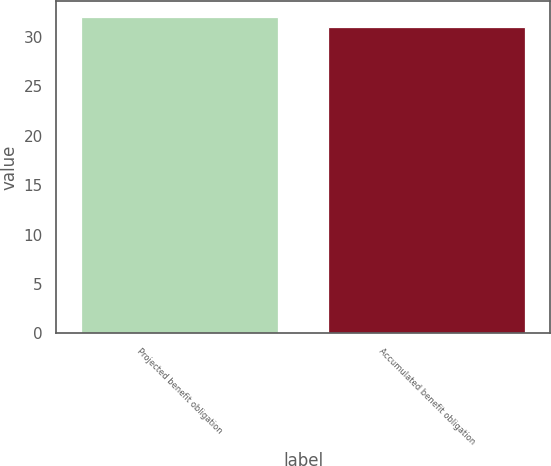Convert chart to OTSL. <chart><loc_0><loc_0><loc_500><loc_500><bar_chart><fcel>Projected benefit obligation<fcel>Accumulated benefit obligation<nl><fcel>32<fcel>31<nl></chart> 